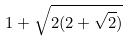<formula> <loc_0><loc_0><loc_500><loc_500>1 + \sqrt { 2 ( 2 + \sqrt { 2 } ) }</formula> 